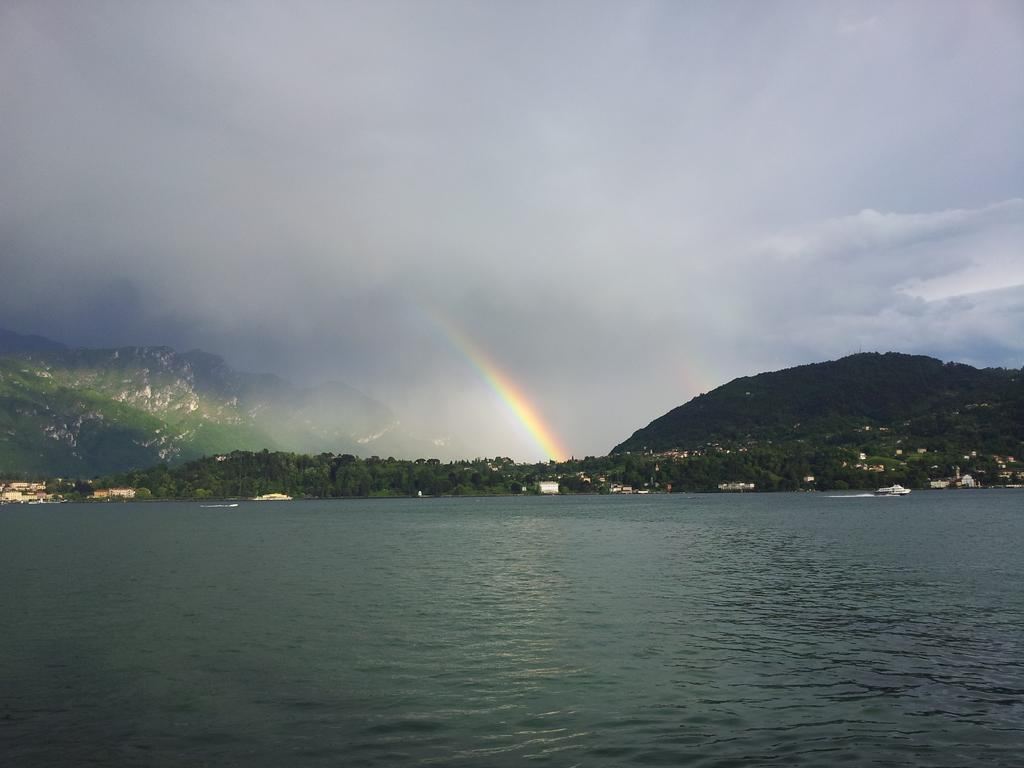What is present in the image that is liquid? There is water in the image. What type of vegetation can be seen in the image? There are trees in the image. What type of structures are visible in the image? There are houses in the image. What is floating on the water in the image? There are boats in the water. What type of landscape feature can be seen in the image? There are hills in the image. How would you describe the sky in the image? The sky is cloudy in the image. What additional feature can be seen in the sky? There is a rainbow in the image. How many men are standing on the rainbow in the image? There are no men present on the rainbow in the image. What type of joke is being told by the trees in the image? There are no jokes being told by the trees in the image. 